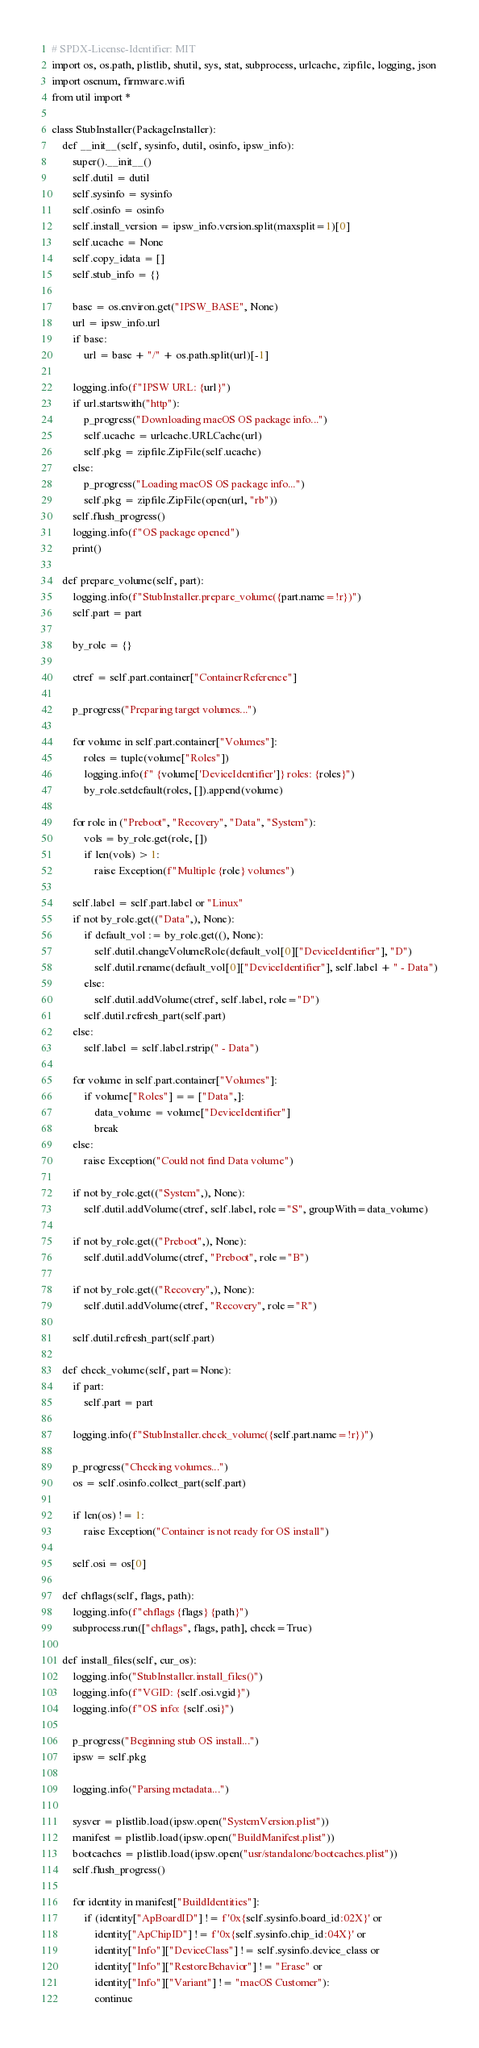<code> <loc_0><loc_0><loc_500><loc_500><_Python_># SPDX-License-Identifier: MIT
import os, os.path, plistlib, shutil, sys, stat, subprocess, urlcache, zipfile, logging, json
import osenum, firmware.wifi
from util import *

class StubInstaller(PackageInstaller):
    def __init__(self, sysinfo, dutil, osinfo, ipsw_info):
        super().__init__()
        self.dutil = dutil
        self.sysinfo = sysinfo
        self.osinfo = osinfo
        self.install_version = ipsw_info.version.split(maxsplit=1)[0]
        self.ucache = None
        self.copy_idata = []
        self.stub_info = {}

        base = os.environ.get("IPSW_BASE", None)
        url = ipsw_info.url
        if base:
            url = base + "/" + os.path.split(url)[-1]

        logging.info(f"IPSW URL: {url}")
        if url.startswith("http"):
            p_progress("Downloading macOS OS package info...")
            self.ucache = urlcache.URLCache(url)
            self.pkg = zipfile.ZipFile(self.ucache)
        else:
            p_progress("Loading macOS OS package info...")
            self.pkg = zipfile.ZipFile(open(url, "rb"))
        self.flush_progress()
        logging.info(f"OS package opened")
        print()

    def prepare_volume(self, part):
        logging.info(f"StubInstaller.prepare_volume({part.name=!r})")
        self.part = part

        by_role = {}

        ctref = self.part.container["ContainerReference"]

        p_progress("Preparing target volumes...")

        for volume in self.part.container["Volumes"]:
            roles = tuple(volume["Roles"])
            logging.info(f" {volume['DeviceIdentifier']} roles: {roles}")
            by_role.setdefault(roles, []).append(volume)

        for role in ("Preboot", "Recovery", "Data", "System"):
            vols = by_role.get(role, [])
            if len(vols) > 1:
                raise Exception(f"Multiple {role} volumes")

        self.label = self.part.label or "Linux"
        if not by_role.get(("Data",), None):
            if default_vol := by_role.get((), None):
                self.dutil.changeVolumeRole(default_vol[0]["DeviceIdentifier"], "D")
                self.dutil.rename(default_vol[0]["DeviceIdentifier"], self.label + " - Data")
            else:
                self.dutil.addVolume(ctref, self.label, role="D")
            self.dutil.refresh_part(self.part)
        else:
            self.label = self.label.rstrip(" - Data")

        for volume in self.part.container["Volumes"]:
            if volume["Roles"] == ["Data",]:
                data_volume = volume["DeviceIdentifier"]
                break
        else:
            raise Exception("Could not find Data volume")

        if not by_role.get(("System",), None):
            self.dutil.addVolume(ctref, self.label, role="S", groupWith=data_volume)

        if not by_role.get(("Preboot",), None):
            self.dutil.addVolume(ctref, "Preboot", role="B")

        if not by_role.get(("Recovery",), None):
            self.dutil.addVolume(ctref, "Recovery", role="R")

        self.dutil.refresh_part(self.part)

    def check_volume(self, part=None):
        if part:
            self.part = part

        logging.info(f"StubInstaller.check_volume({self.part.name=!r})")

        p_progress("Checking volumes...")
        os = self.osinfo.collect_part(self.part)

        if len(os) != 1:
            raise Exception("Container is not ready for OS install")

        self.osi = os[0]

    def chflags(self, flags, path):
        logging.info(f"chflags {flags} {path}")
        subprocess.run(["chflags", flags, path], check=True)

    def install_files(self, cur_os):
        logging.info("StubInstaller.install_files()")
        logging.info(f"VGID: {self.osi.vgid}")
        logging.info(f"OS info: {self.osi}")

        p_progress("Beginning stub OS install...")
        ipsw = self.pkg

        logging.info("Parsing metadata...")

        sysver = plistlib.load(ipsw.open("SystemVersion.plist"))
        manifest = plistlib.load(ipsw.open("BuildManifest.plist"))
        bootcaches = plistlib.load(ipsw.open("usr/standalone/bootcaches.plist"))
        self.flush_progress()

        for identity in manifest["BuildIdentities"]:
            if (identity["ApBoardID"] != f'0x{self.sysinfo.board_id:02X}' or
                identity["ApChipID"] != f'0x{self.sysinfo.chip_id:04X}' or
                identity["Info"]["DeviceClass"] != self.sysinfo.device_class or
                identity["Info"]["RestoreBehavior"] != "Erase" or
                identity["Info"]["Variant"] != "macOS Customer"):
                continue</code> 